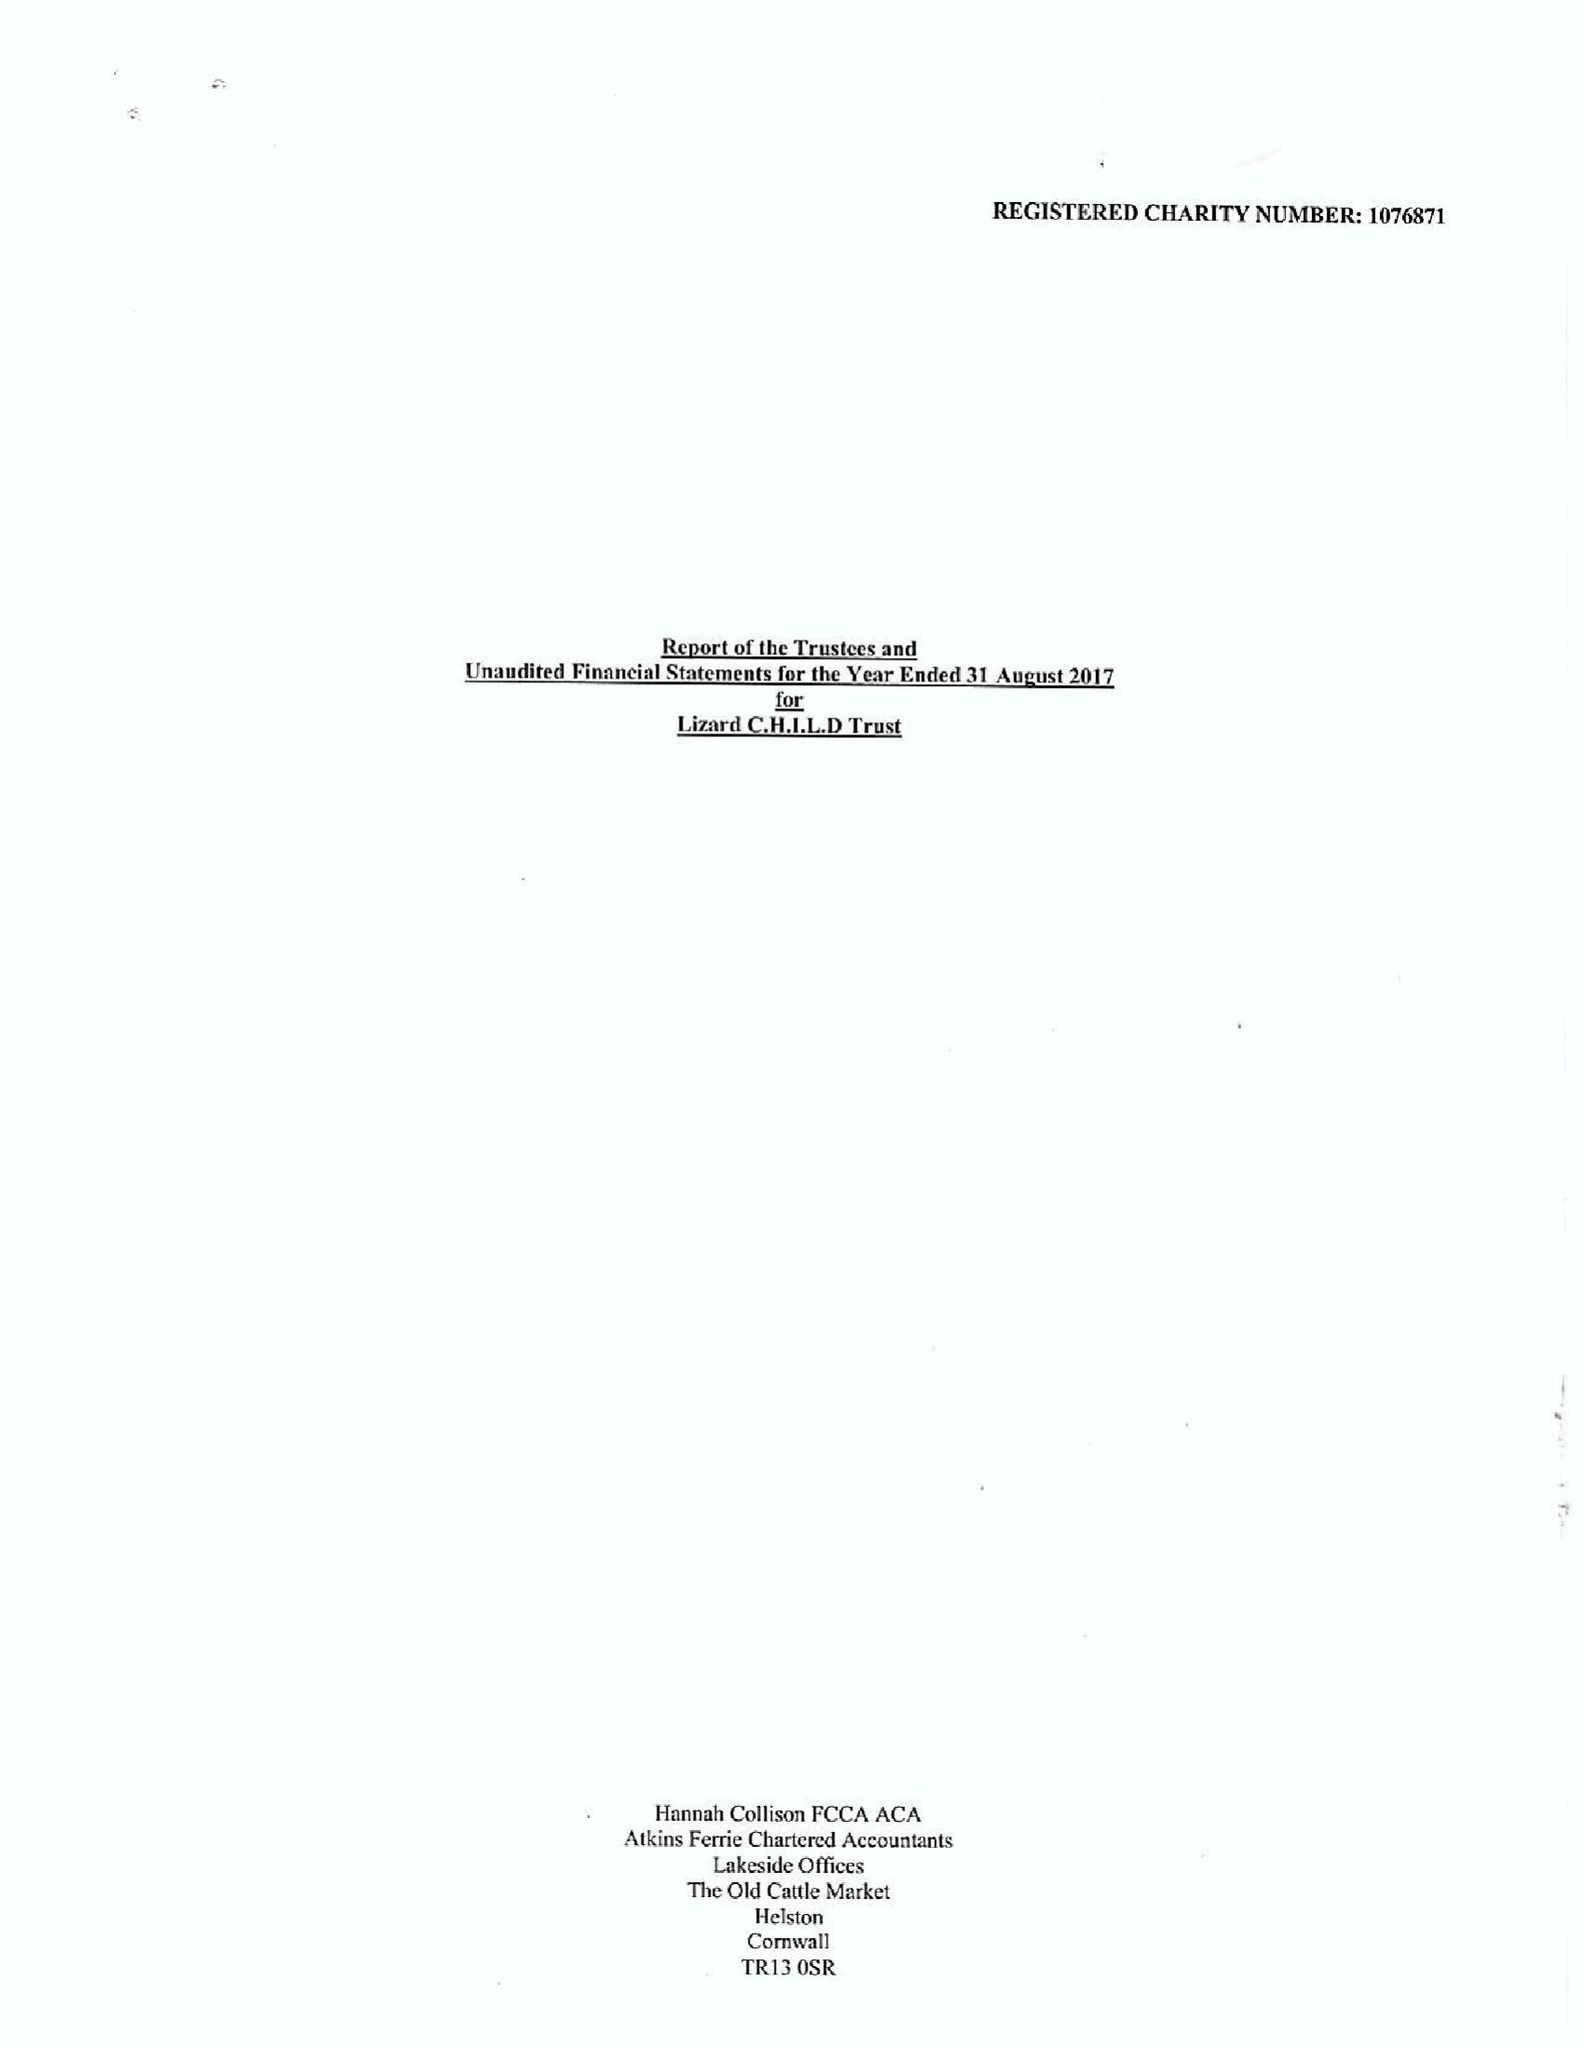What is the value for the charity_number?
Answer the question using a single word or phrase. 1076871 